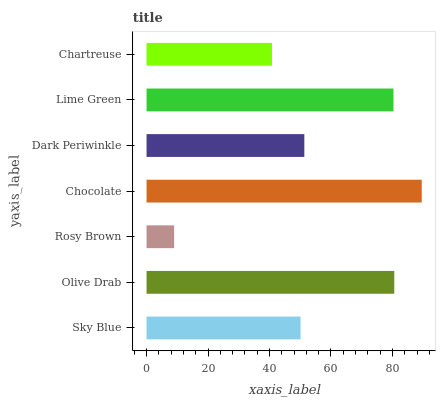Is Rosy Brown the minimum?
Answer yes or no. Yes. Is Chocolate the maximum?
Answer yes or no. Yes. Is Olive Drab the minimum?
Answer yes or no. No. Is Olive Drab the maximum?
Answer yes or no. No. Is Olive Drab greater than Sky Blue?
Answer yes or no. Yes. Is Sky Blue less than Olive Drab?
Answer yes or no. Yes. Is Sky Blue greater than Olive Drab?
Answer yes or no. No. Is Olive Drab less than Sky Blue?
Answer yes or no. No. Is Dark Periwinkle the high median?
Answer yes or no. Yes. Is Dark Periwinkle the low median?
Answer yes or no. Yes. Is Chartreuse the high median?
Answer yes or no. No. Is Rosy Brown the low median?
Answer yes or no. No. 